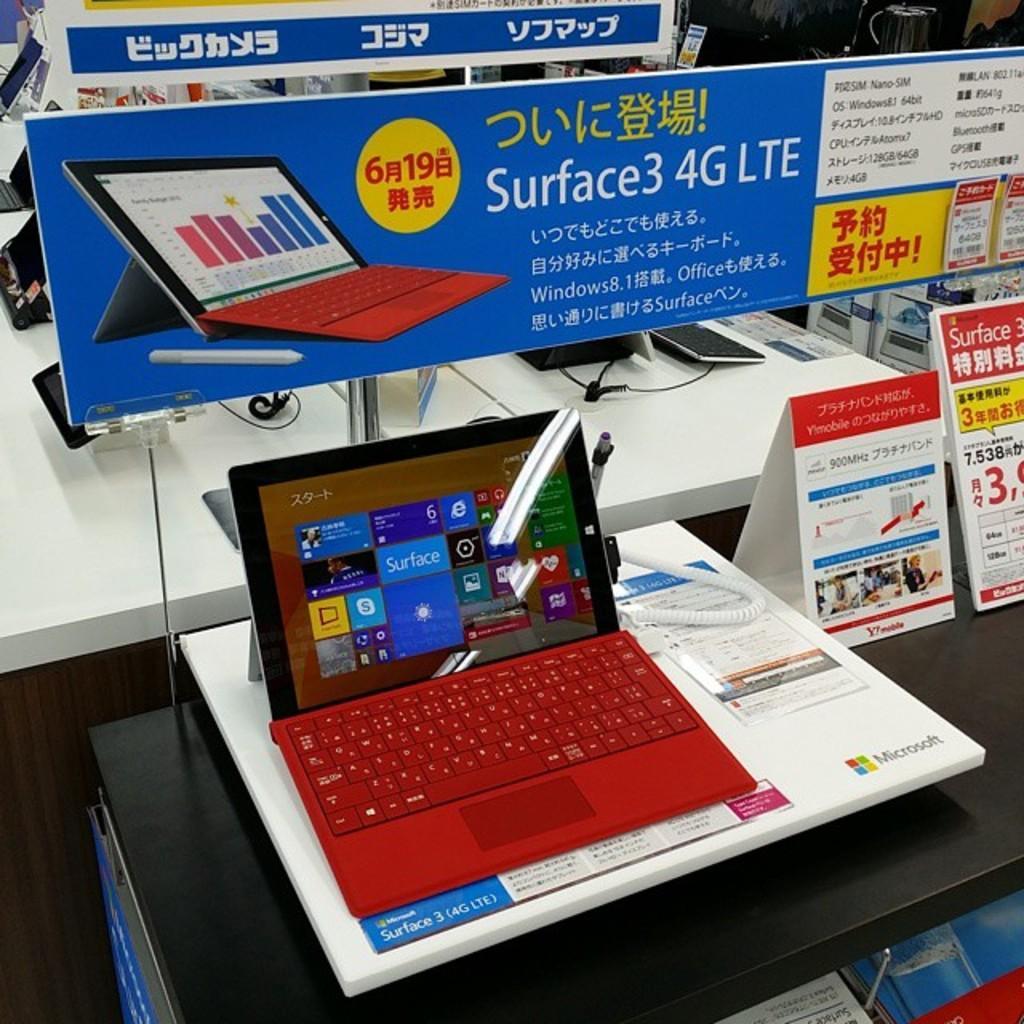Can you describe this image briefly? In this image, we can see a laptop and there is a banners and some words, we can see a white color table. 